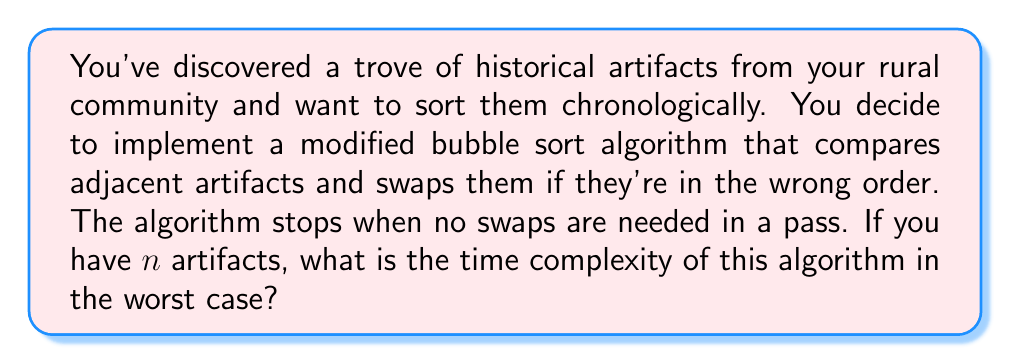Can you answer this question? To analyze the time complexity of this modified bubble sort algorithm, let's break it down step-by-step:

1) In the worst case scenario, the artifacts are in reverse chronological order.

2) For each pass through the list of $n$ artifacts:
   - We compare each adjacent pair of artifacts.
   - In the worst case, we make $(n-1)$ comparisons per pass.
   - We might need to swap each pair, leading to $(n-1)$ swaps per pass.

3) The number of passes required in the worst case:
   - We need $(n-1)$ passes to fully sort the list.
   - This is because in each pass, at least one artifact "bubbles up" to its correct position.

4) Total number of operations:
   - Comparisons: $(n-1)$ comparisons per pass * $(n-1)$ passes = $(n-1)^2$
   - Swaps: $(n-1)$ swaps per pass * $(n-1)$ passes = $(n-1)^2$

5) Total operations: $2(n-1)^2$

6) In Big O notation, we ignore constants and lower order terms. So, $2(n-1)^2$ simplifies to $O(n^2)$.

Therefore, the worst-case time complexity of this modified bubble sort algorithm is $O(n^2)$.
Answer: $O(n^2)$ 